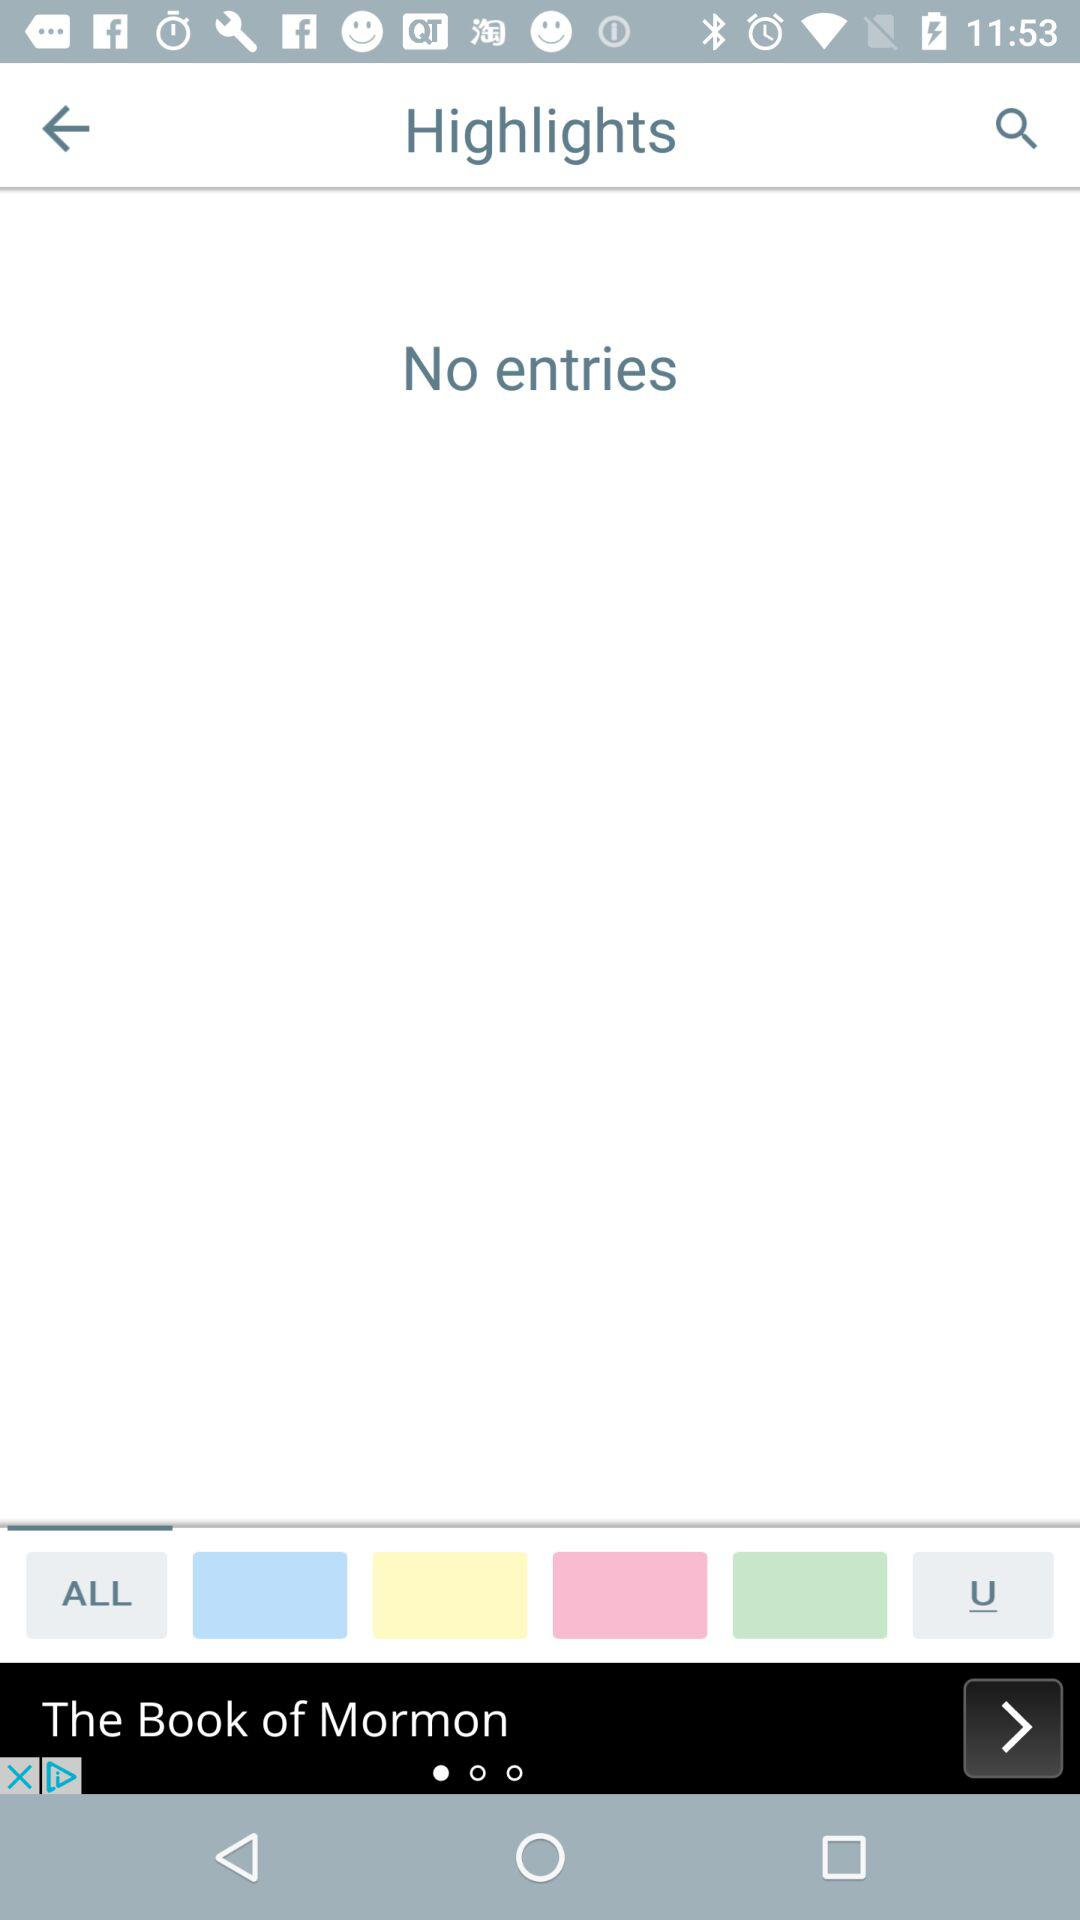When was the last entry made?
When the provided information is insufficient, respond with <no answer>. <no answer> 